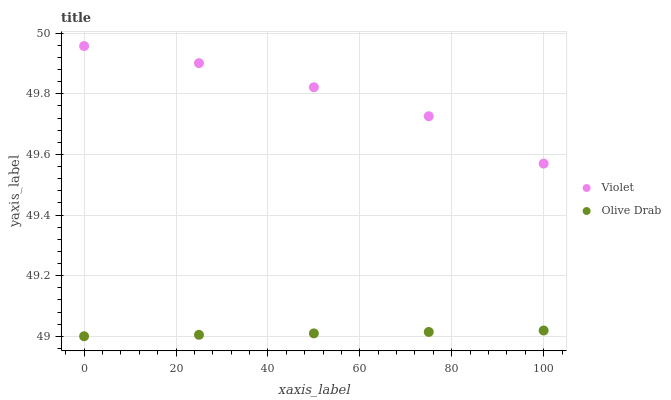Does Olive Drab have the minimum area under the curve?
Answer yes or no. Yes. Does Violet have the maximum area under the curve?
Answer yes or no. Yes. Does Violet have the minimum area under the curve?
Answer yes or no. No. Is Olive Drab the smoothest?
Answer yes or no. Yes. Is Violet the roughest?
Answer yes or no. Yes. Is Violet the smoothest?
Answer yes or no. No. Does Olive Drab have the lowest value?
Answer yes or no. Yes. Does Violet have the lowest value?
Answer yes or no. No. Does Violet have the highest value?
Answer yes or no. Yes. Is Olive Drab less than Violet?
Answer yes or no. Yes. Is Violet greater than Olive Drab?
Answer yes or no. Yes. Does Olive Drab intersect Violet?
Answer yes or no. No. 